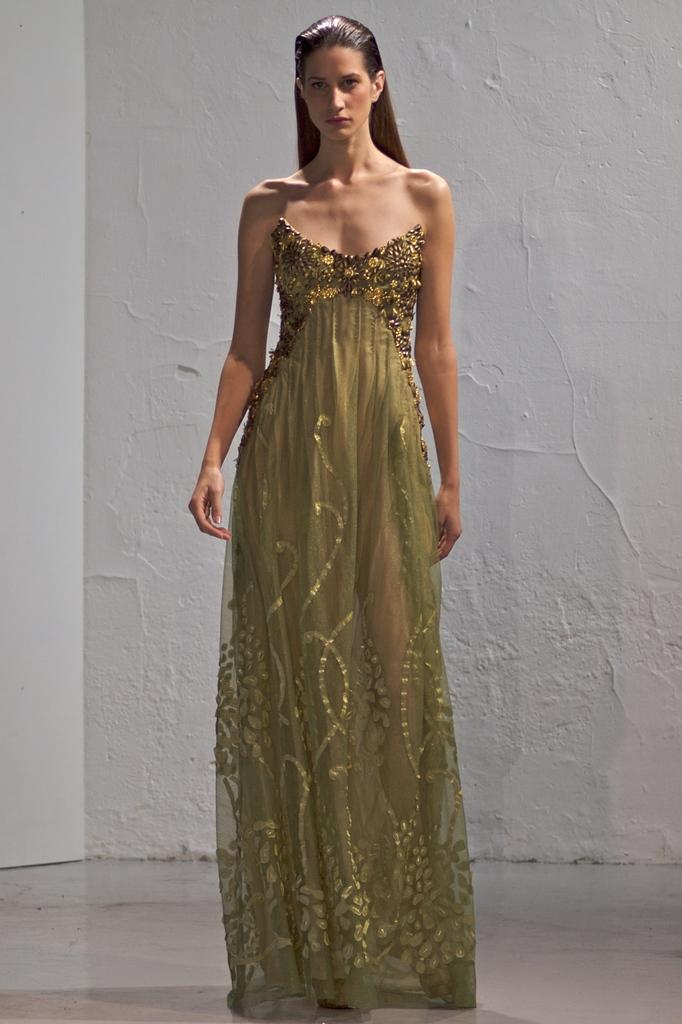What is the main subject of the image? There is a woman standing in the image. Can you describe the background of the image? There is a wall in the background of the image. What type of beetle can be seen crawling on the woman's shoulder in the image? There is no beetle present on the woman's shoulder in the image. What range of motion does the woman have in the image? The image only shows a static pose of the woman, so it is not possible to determine her range of motion. 